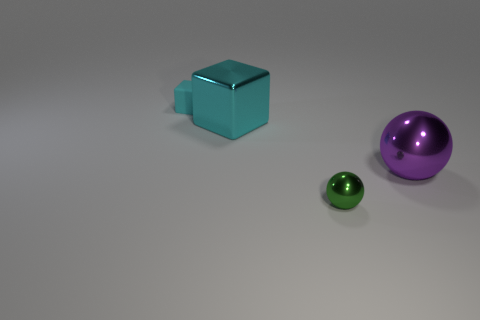Add 3 brown metallic objects. How many brown metallic objects exist? 3 Add 4 tiny blue matte blocks. How many objects exist? 8 Subtract 0 purple blocks. How many objects are left? 4 Subtract 1 blocks. How many blocks are left? 1 Subtract all green balls. Subtract all yellow blocks. How many balls are left? 1 Subtract all purple cubes. How many green balls are left? 1 Subtract all small gray rubber balls. Subtract all large purple metallic objects. How many objects are left? 3 Add 1 tiny matte things. How many tiny matte things are left? 2 